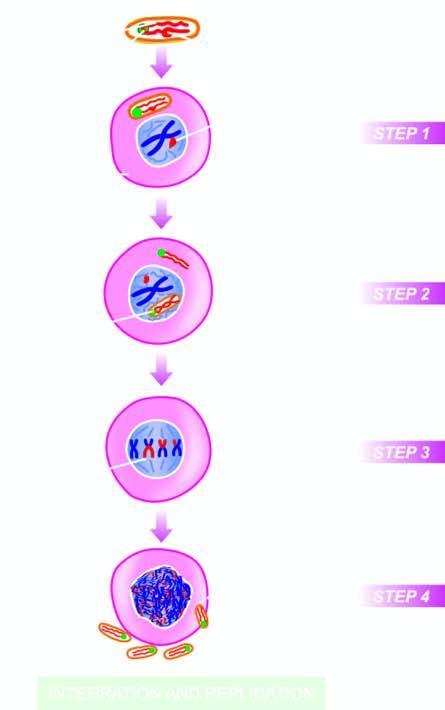re the granuloma released into the cytosol?
Answer the question using a single word or phrase. No 